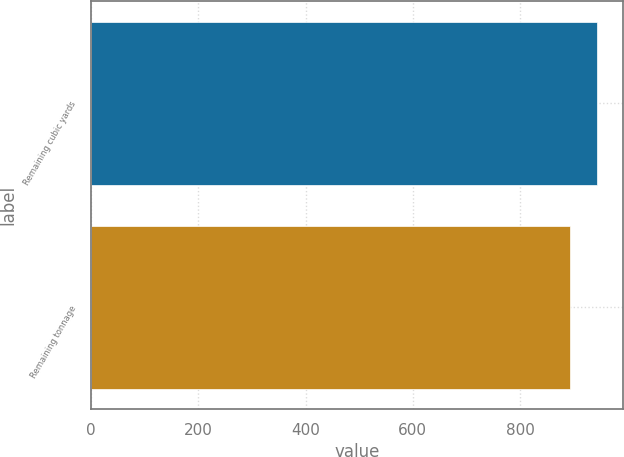<chart> <loc_0><loc_0><loc_500><loc_500><bar_chart><fcel>Remaining cubic yards<fcel>Remaining tonnage<nl><fcel>944<fcel>893<nl></chart> 